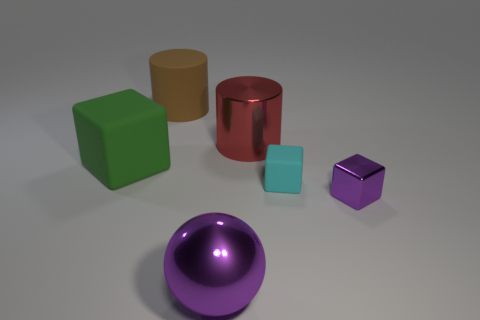How many other things are there of the same size as the cyan matte cube?
Your answer should be very brief. 1. There is a big purple metal sphere; are there any brown cylinders in front of it?
Keep it short and to the point. No. There is a large rubber block; is its color the same as the small thing that is to the right of the small rubber thing?
Offer a very short reply. No. The matte cube to the right of the metallic object behind the purple object behind the large shiny ball is what color?
Offer a very short reply. Cyan. Is there a big gray thing of the same shape as the green matte object?
Make the answer very short. No. What color is the thing that is the same size as the purple shiny cube?
Make the answer very short. Cyan. What is the material of the small block that is in front of the cyan cube?
Make the answer very short. Metal. Is the shape of the big rubber thing that is to the right of the green rubber cube the same as the purple thing that is right of the tiny cyan matte thing?
Offer a very short reply. No. Are there the same number of large green objects that are on the right side of the big purple metal sphere and big green objects?
Your answer should be compact. No. What number of other small blocks have the same material as the cyan cube?
Provide a succinct answer. 0. 